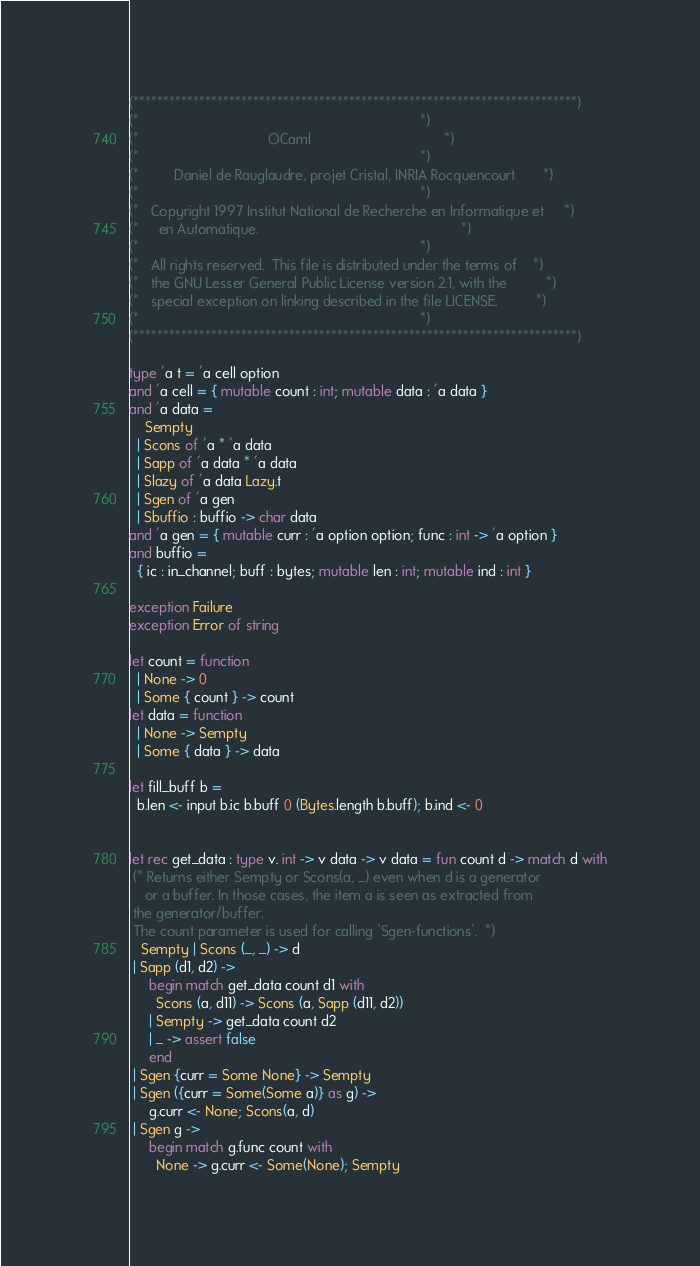Convert code to text. <code><loc_0><loc_0><loc_500><loc_500><_OCaml_>(**************************************************************************)
(*                                                                        *)
(*                                 OCaml                                  *)
(*                                                                        *)
(*         Daniel de Rauglaudre, projet Cristal, INRIA Rocquencourt       *)
(*                                                                        *)
(*   Copyright 1997 Institut National de Recherche en Informatique et     *)
(*     en Automatique.                                                    *)
(*                                                                        *)
(*   All rights reserved.  This file is distributed under the terms of    *)
(*   the GNU Lesser General Public License version 2.1, with the          *)
(*   special exception on linking described in the file LICENSE.          *)
(*                                                                        *)
(**************************************************************************)

type 'a t = 'a cell option
and 'a cell = { mutable count : int; mutable data : 'a data }
and 'a data =
    Sempty
  | Scons of 'a * 'a data
  | Sapp of 'a data * 'a data
  | Slazy of 'a data Lazy.t
  | Sgen of 'a gen
  | Sbuffio : buffio -> char data
and 'a gen = { mutable curr : 'a option option; func : int -> 'a option }
and buffio =
  { ic : in_channel; buff : bytes; mutable len : int; mutable ind : int }

exception Failure
exception Error of string

let count = function
  | None -> 0
  | Some { count } -> count
let data = function
  | None -> Sempty
  | Some { data } -> data

let fill_buff b =
  b.len <- input b.ic b.buff 0 (Bytes.length b.buff); b.ind <- 0


let rec get_data : type v. int -> v data -> v data = fun count d -> match d with
 (* Returns either Sempty or Scons(a, _) even when d is a generator
    or a buffer. In those cases, the item a is seen as extracted from
 the generator/buffer.
 The count parameter is used for calling `Sgen-functions'.  *)
   Sempty | Scons (_, _) -> d
 | Sapp (d1, d2) ->
     begin match get_data count d1 with
       Scons (a, d11) -> Scons (a, Sapp (d11, d2))
     | Sempty -> get_data count d2
     | _ -> assert false
     end
 | Sgen {curr = Some None} -> Sempty
 | Sgen ({curr = Some(Some a)} as g) ->
     g.curr <- None; Scons(a, d)
 | Sgen g ->
     begin match g.func count with
       None -> g.curr <- Some(None); Sempty</code> 